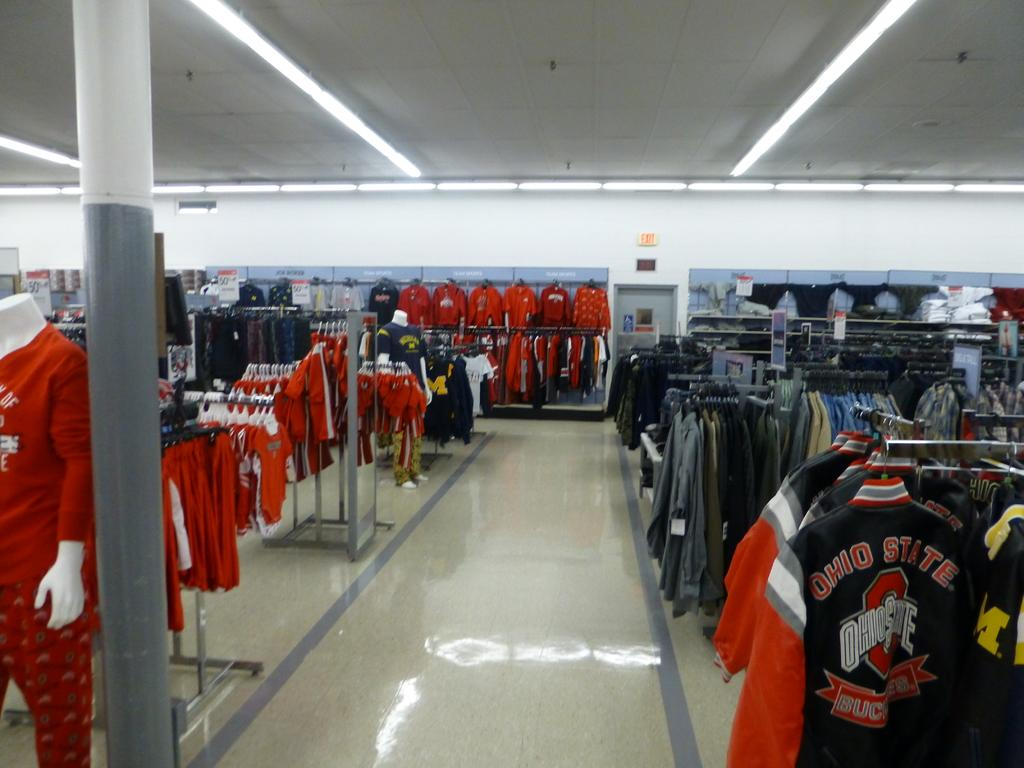<image>
Offer a succinct explanation of the picture presented. A clothing store featuring a lot of Ohio State clothing. 